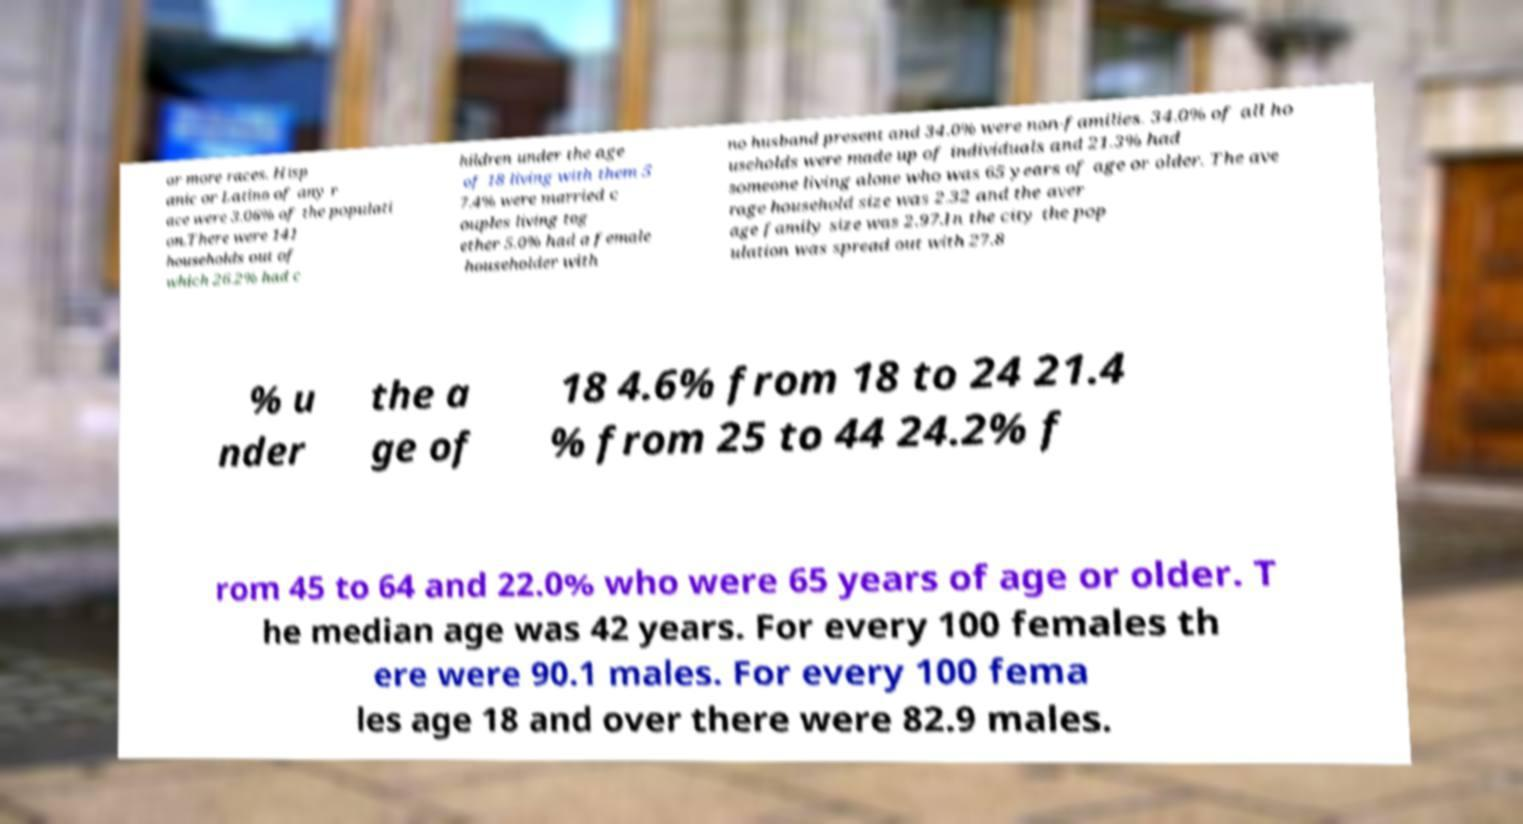Could you assist in decoding the text presented in this image and type it out clearly? or more races. Hisp anic or Latino of any r ace were 3.06% of the populati on.There were 141 households out of which 26.2% had c hildren under the age of 18 living with them 5 7.4% were married c ouples living tog ether 5.0% had a female householder with no husband present and 34.0% were non-families. 34.0% of all ho useholds were made up of individuals and 21.3% had someone living alone who was 65 years of age or older. The ave rage household size was 2.32 and the aver age family size was 2.97.In the city the pop ulation was spread out with 27.8 % u nder the a ge of 18 4.6% from 18 to 24 21.4 % from 25 to 44 24.2% f rom 45 to 64 and 22.0% who were 65 years of age or older. T he median age was 42 years. For every 100 females th ere were 90.1 males. For every 100 fema les age 18 and over there were 82.9 males. 